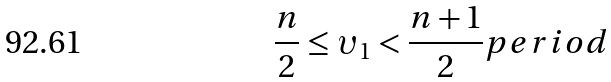Convert formula to latex. <formula><loc_0><loc_0><loc_500><loc_500>\frac { n } { 2 } \leq \upsilon _ { 1 } < \frac { n + 1 } { 2 } p e r i o d</formula> 